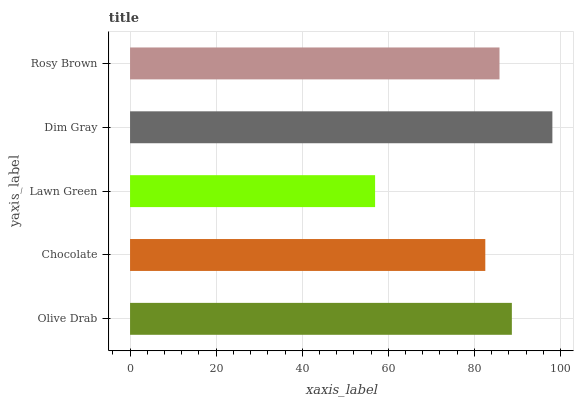Is Lawn Green the minimum?
Answer yes or no. Yes. Is Dim Gray the maximum?
Answer yes or no. Yes. Is Chocolate the minimum?
Answer yes or no. No. Is Chocolate the maximum?
Answer yes or no. No. Is Olive Drab greater than Chocolate?
Answer yes or no. Yes. Is Chocolate less than Olive Drab?
Answer yes or no. Yes. Is Chocolate greater than Olive Drab?
Answer yes or no. No. Is Olive Drab less than Chocolate?
Answer yes or no. No. Is Rosy Brown the high median?
Answer yes or no. Yes. Is Rosy Brown the low median?
Answer yes or no. Yes. Is Chocolate the high median?
Answer yes or no. No. Is Chocolate the low median?
Answer yes or no. No. 